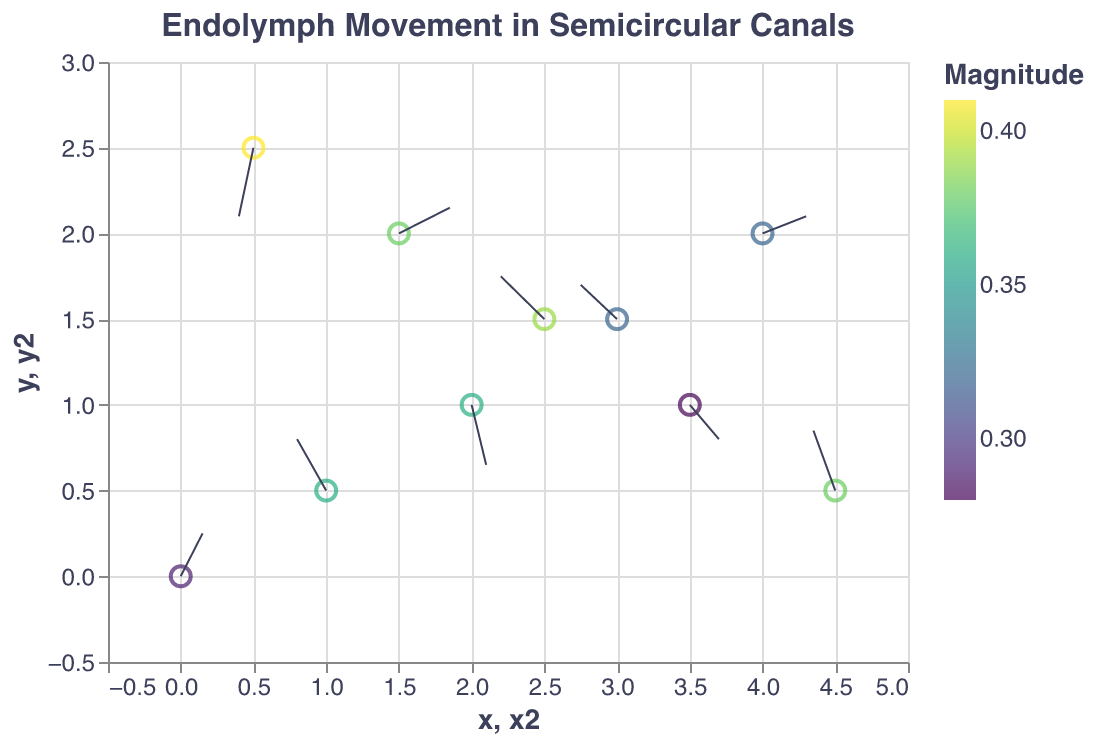What is the title of the quiver plot? The title is clearly mentioned at the top of the plot, which is "Endolymph Movement in Semicircular Canals."
Answer: Endolymph Movement in Semicircular Canals How many data points are represented in the plot? By counting the number of points or arrows present in the plot, we observe that there are 10 data points.
Answer: 10 Which data point has the highest magnitude? We can find the magnitude values marked with color, and the data point at (0.5, 2.5) shows the highest magnitude of 0.41 based on the color legend.
Answer: (0.5, 2.5) What is the direction of movement at the point (1, 0.5)? The direction of movement can be determined by the vectors (u, v). For the point (1, 0.5), the vector is (-0.2, 0.3), indicating it moves left and slightly upward.
Answer: Left and up Which point has the minimum x component of the vector? Comparing the x components (u), the points at (1, 0.5) and (4.5, 0.5) have the most negative x component of -0.2 and -0.15, respectively. The minimum is -0.2 at (1, 0.5).
Answer: (1, 0.5) What is the total magnitude at points where 'y' is equal to 1? Summing up the magnitudes where y = 1 (points at (2, 1) and (3.5, 1)), we get 0.36 + 0.28 = 0.64.
Answer: 0.64 Which data point represents a downward movement? Observing the 'v' components of the vectors, the points with negative 'v' values indicate downward movements. For example, (2, 1) with v = -0.35 and (0.5, 2.5) with v = -0.4.
Answer: (2, 1) and (0.5, 2.5) What is the average magnitude of all the data points? Adding all magnitude values and then dividing by the number of points: (0.29 + 0.36 + 0.36 + 0.32 + 0.32 + 0.41 + 0.38 + 0.39 + 0.28 + 0.38)/10 = 3.49 / 10 = 0.349.
Answer: 0.349 Which vectors indicate a rightward movement? Vectors with a positive 'u' component indicate rightward movement. These points are (0, 0) with u = 0.15, (2, 1) with u = 0.1, (4, 2) with u = 0.3, (1.5, 2) with u = 0.35, and (3.5, 1) with u = 0.2.
Answer: (0, 0), (2, 1), (4, 2), (1.5, 2), (3.5, 1) Which point is closest to the origin (0, 0)? We measure the Euclidean distance from (0, 0) for each point and confirm that (0, 0) itself is closest to the origin.
Answer: (0, 0) 